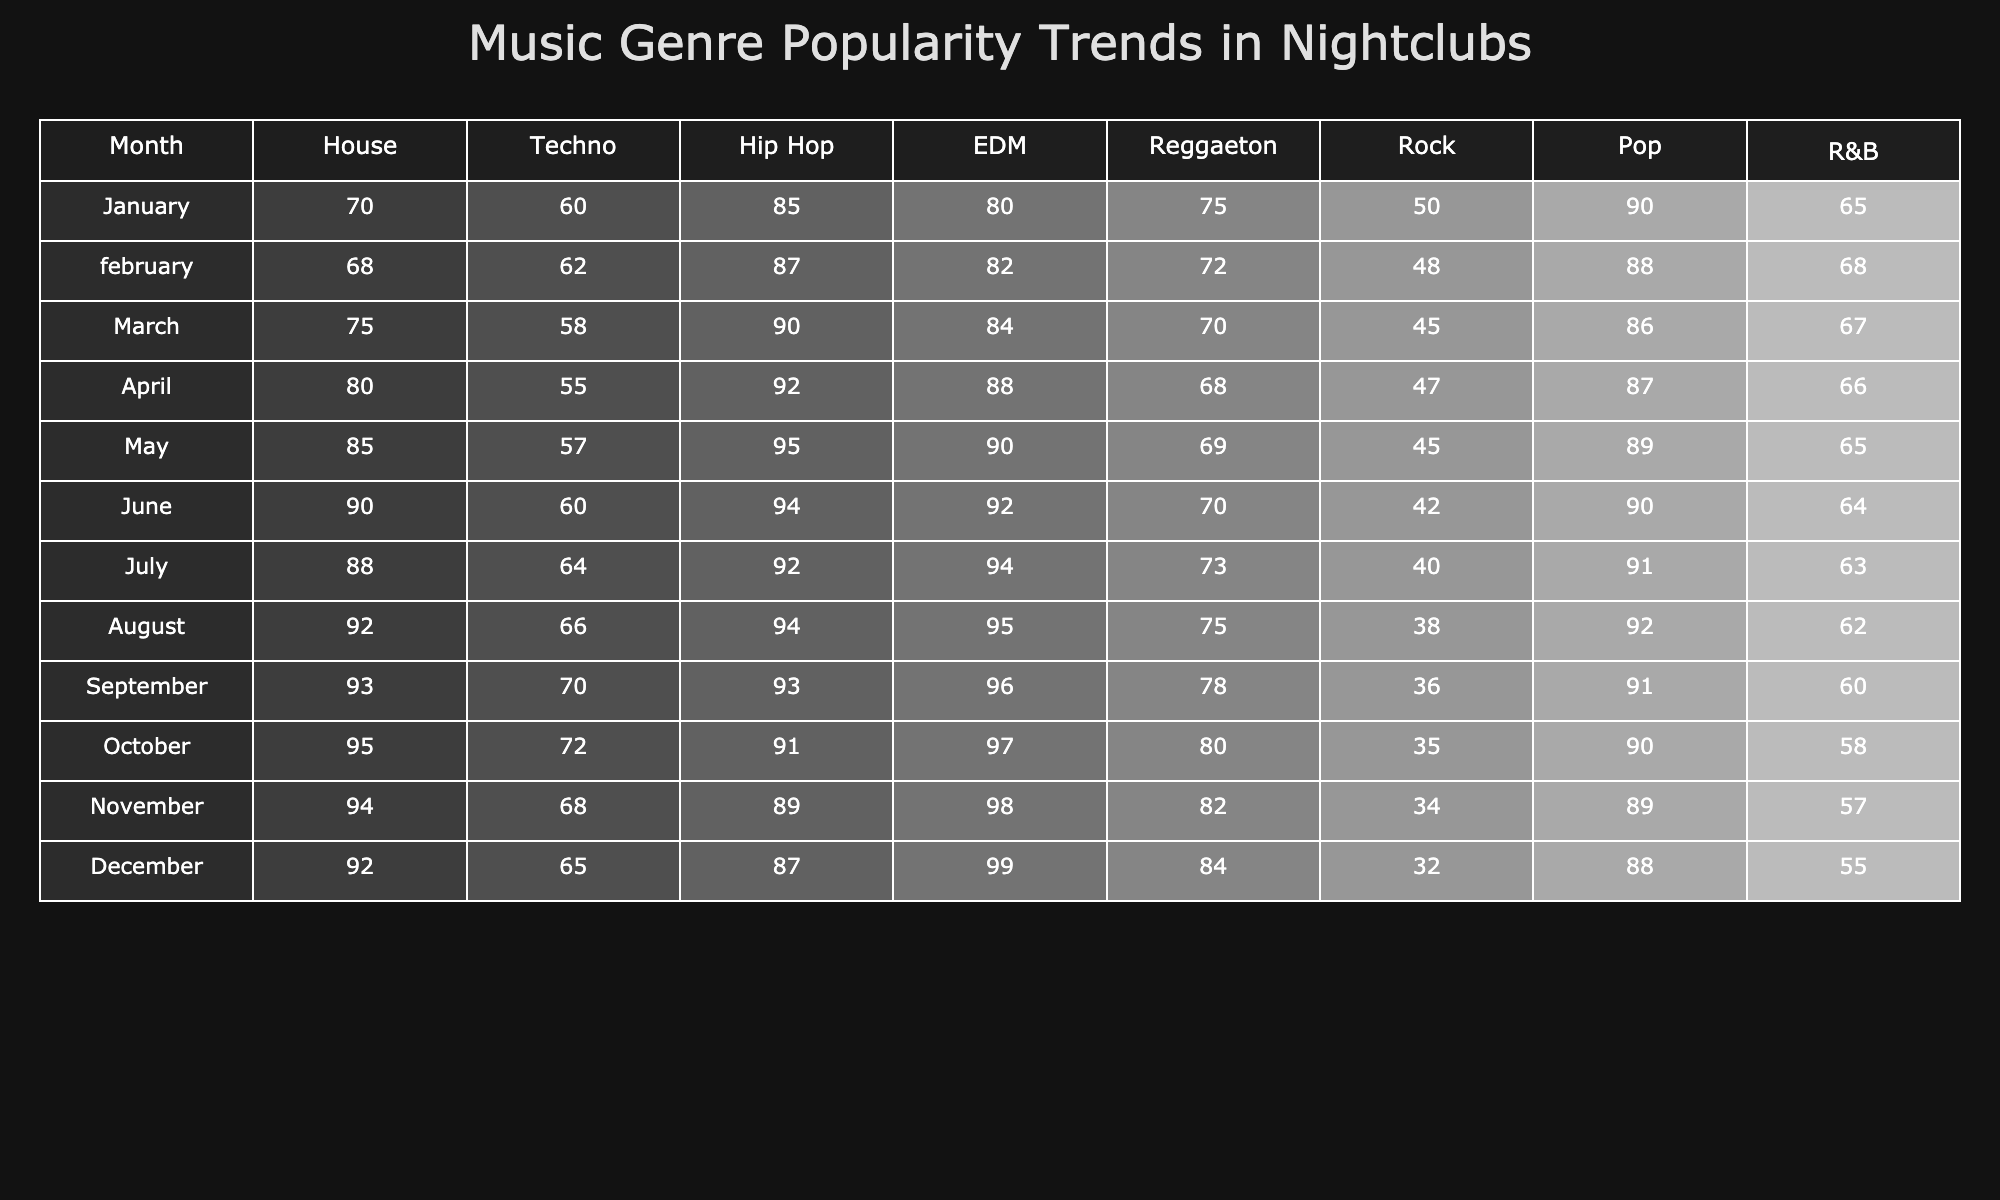What was the highest popularity score for EDM, and in which month did it occur? The highest popularity score for EDM is 99, which occurred in December.
Answer: 99, December Which genre had the lowest popularity in July? In July, the genre with the lowest popularity was Rock, with a score of 40.
Answer: Rock, 40 What is the average popularity score for Hip Hop over the year? To find the average, sum the scores for Hip Hop from January to December: (85 + 87 + 90 + 92 + 95 + 94 + 92 + 94 + 93 + 91 + 89 + 87) = 1,121; dividing by 12 gives a result of approximately 93.42.
Answer: 93.42 Did Reggaeton's popularity increase or decrease from January to December? Reggaeton's popularity decreased from January (75) to December (84) since the December score is higher than January.
Answer: Yes, it increased What was the overall trend for Pop throughout the year? The trend for Pop shows a peak in January (90), followed by a decrease to 86 in March, then fluctuated around 89 and 90 until decreasing to 88 in December, indicating a general stability with slight fluctuations.
Answer: General stability with fluctuations 